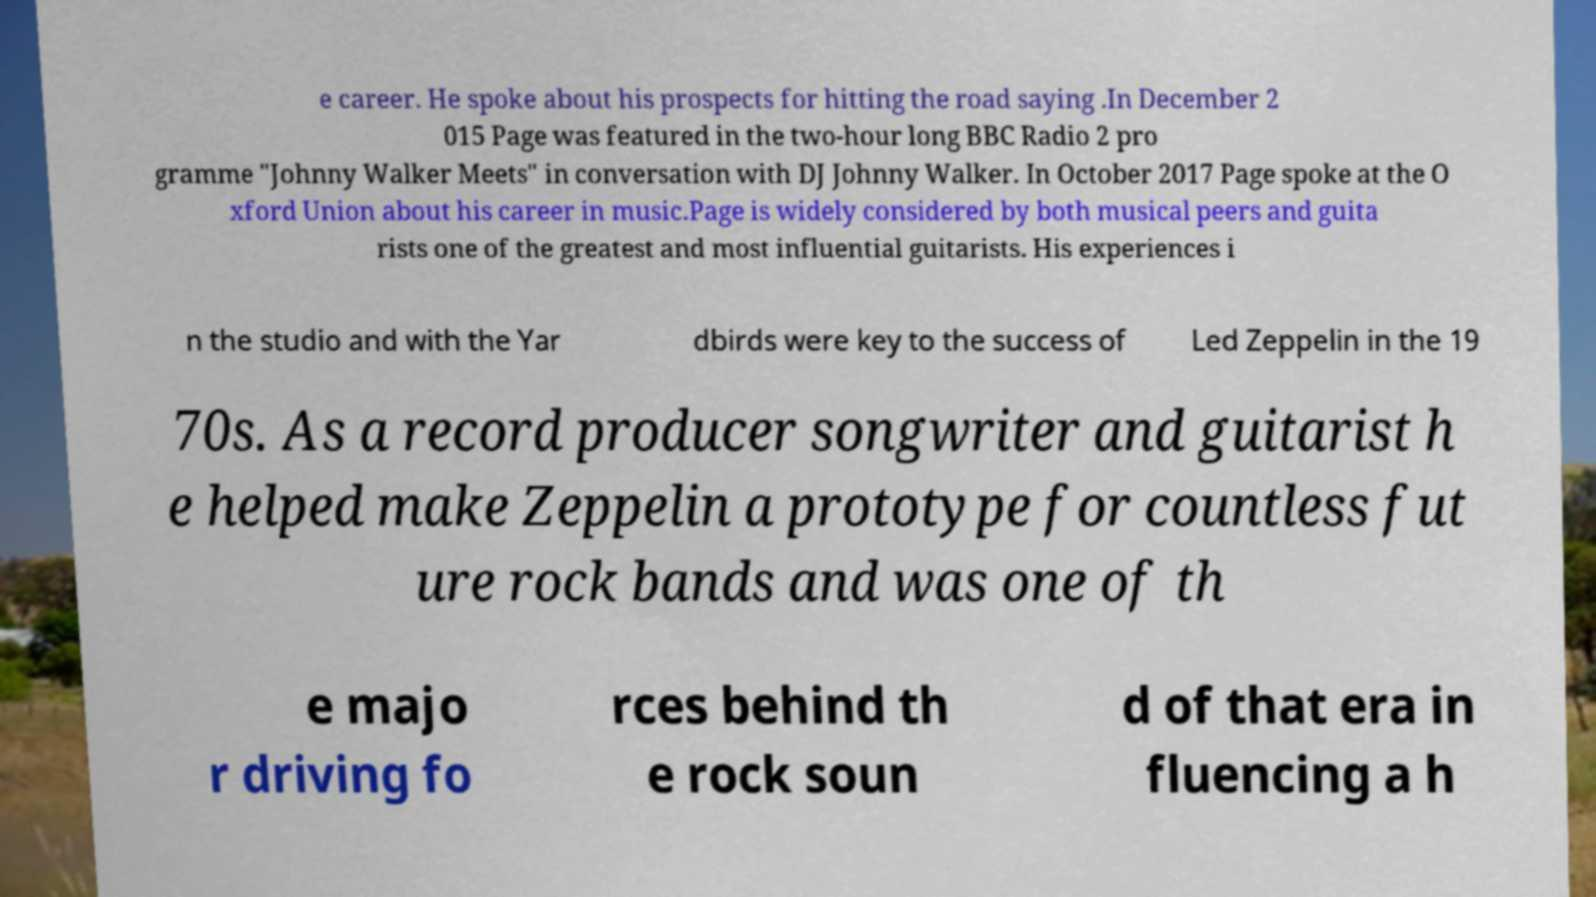Please read and relay the text visible in this image. What does it say? e career. He spoke about his prospects for hitting the road saying .In December 2 015 Page was featured in the two-hour long BBC Radio 2 pro gramme "Johnny Walker Meets" in conversation with DJ Johnny Walker. In October 2017 Page spoke at the O xford Union about his career in music.Page is widely considered by both musical peers and guita rists one of the greatest and most influential guitarists. His experiences i n the studio and with the Yar dbirds were key to the success of Led Zeppelin in the 19 70s. As a record producer songwriter and guitarist h e helped make Zeppelin a prototype for countless fut ure rock bands and was one of th e majo r driving fo rces behind th e rock soun d of that era in fluencing a h 